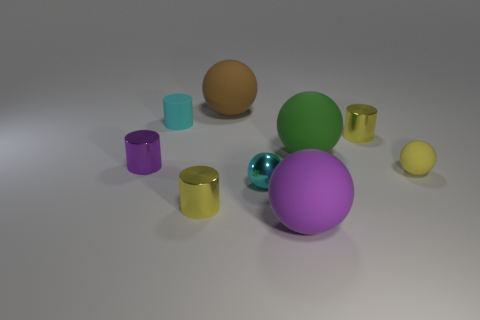Can you tell me about the lighting in the image? Does it create any shadows or reflections on the surface? Yes, the lighting in the image appears to be coming from the upper left, casting soft shadows on the right-hand side of the objects. The spherical shapes create distinct circular shadows, whereas the cylinders produce elongated ones. Notably, the shadows suggest a single light source. Additionally, surfaces with metallic finishes, especially the gold and purple cylinders, show subtle reflections of other objects, highlighting their glossy texture. 